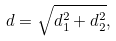<formula> <loc_0><loc_0><loc_500><loc_500>d = \sqrt { d _ { 1 } ^ { 2 } + d _ { 2 } ^ { 2 } } ,</formula> 